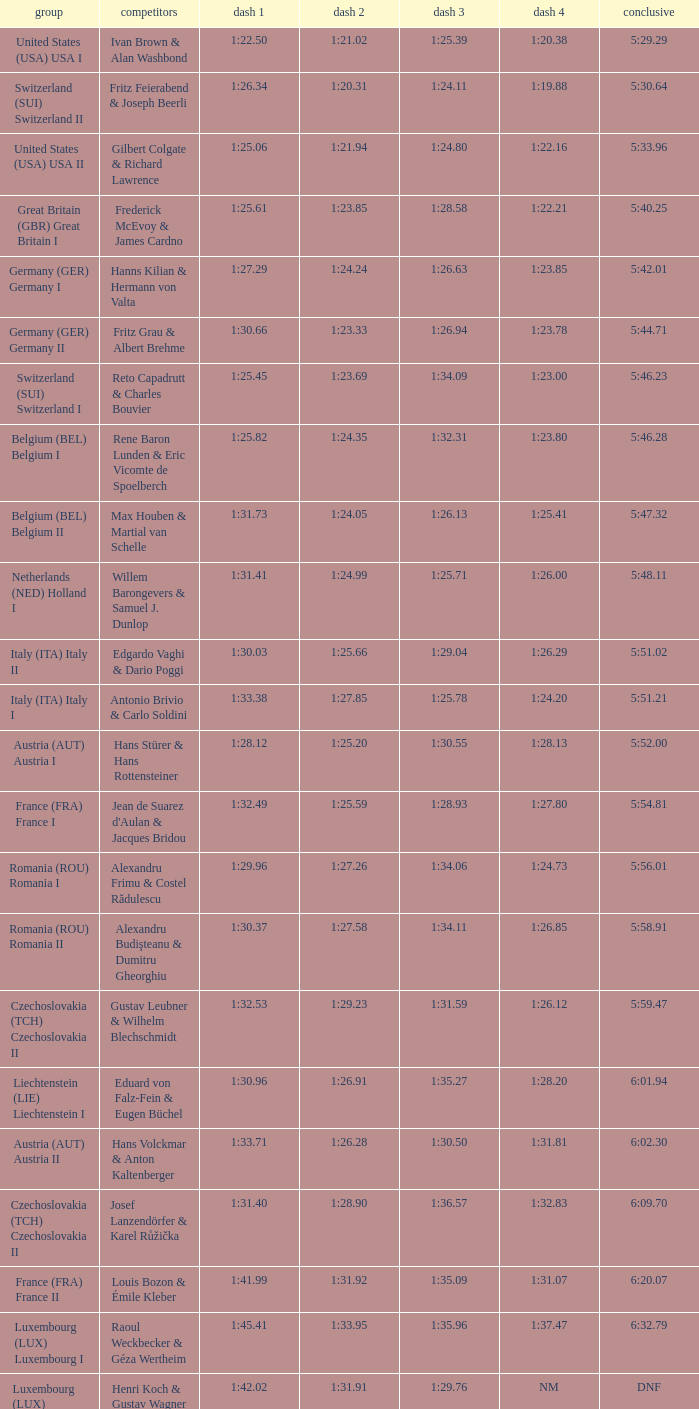Which Final has a Run 2 of 1:27.58? 5:58.91. 